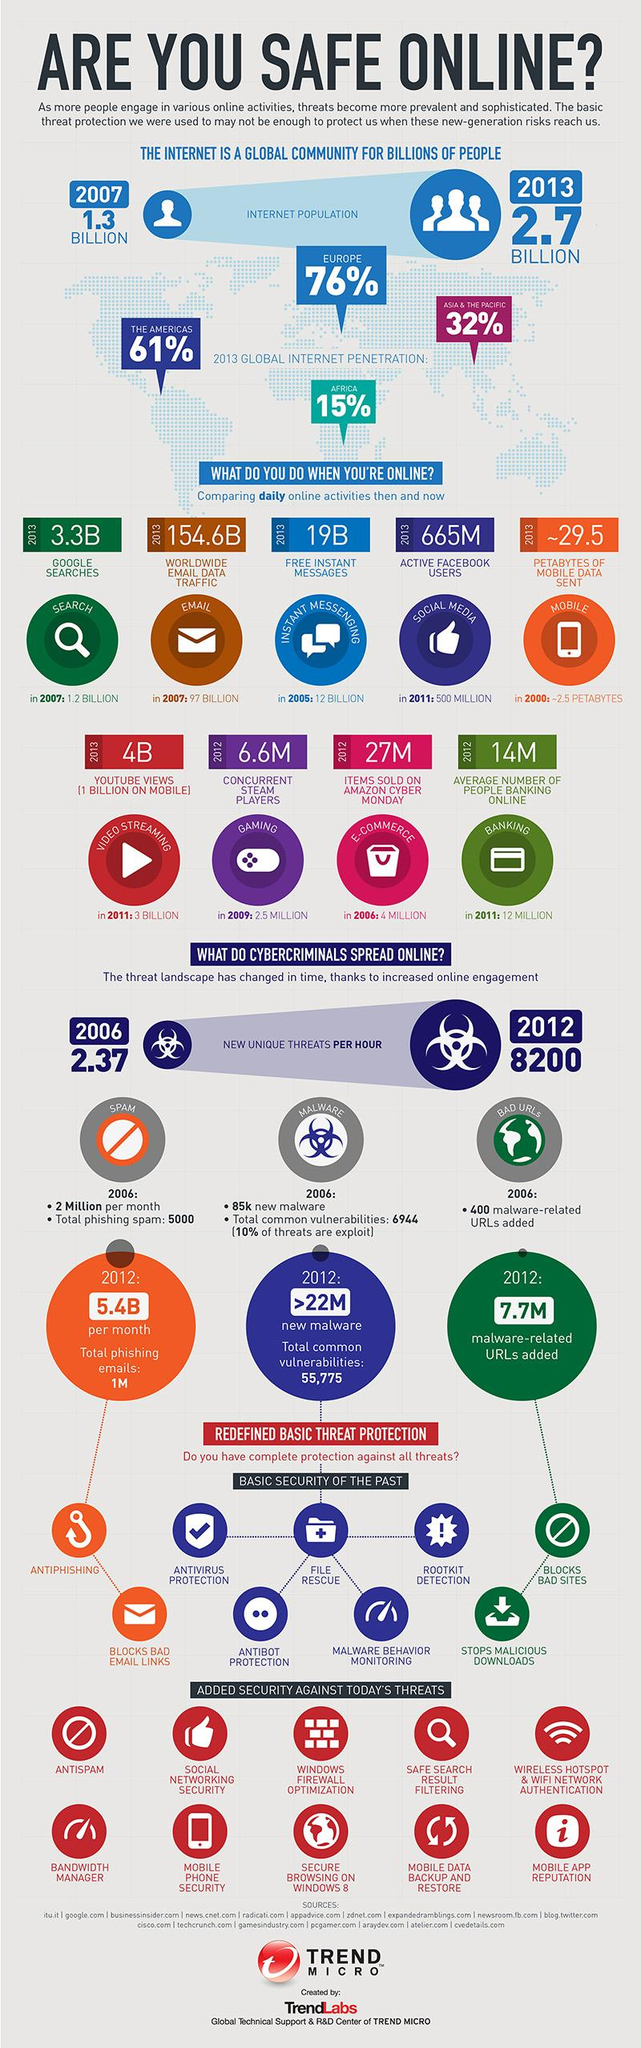Highlight a few significant elements in this photo. In 2011, the average number of people banking online was 12 million. In 2013, there were approximately 19 billion free instant messages. As of 2013, there were approximately 665 million active users of Facebook. In 2009, there were 2.5 million users of a specific online activity. This activity was particularly popular among users, as evidenced by the significant number of individuals who engaged in it. It is likely that this online activity was related to gaming, as the mention of this specific activity in the original sentence suggests. According to estimates, in 2000 approximately 2.5 petabytes of mobile data was sent. 